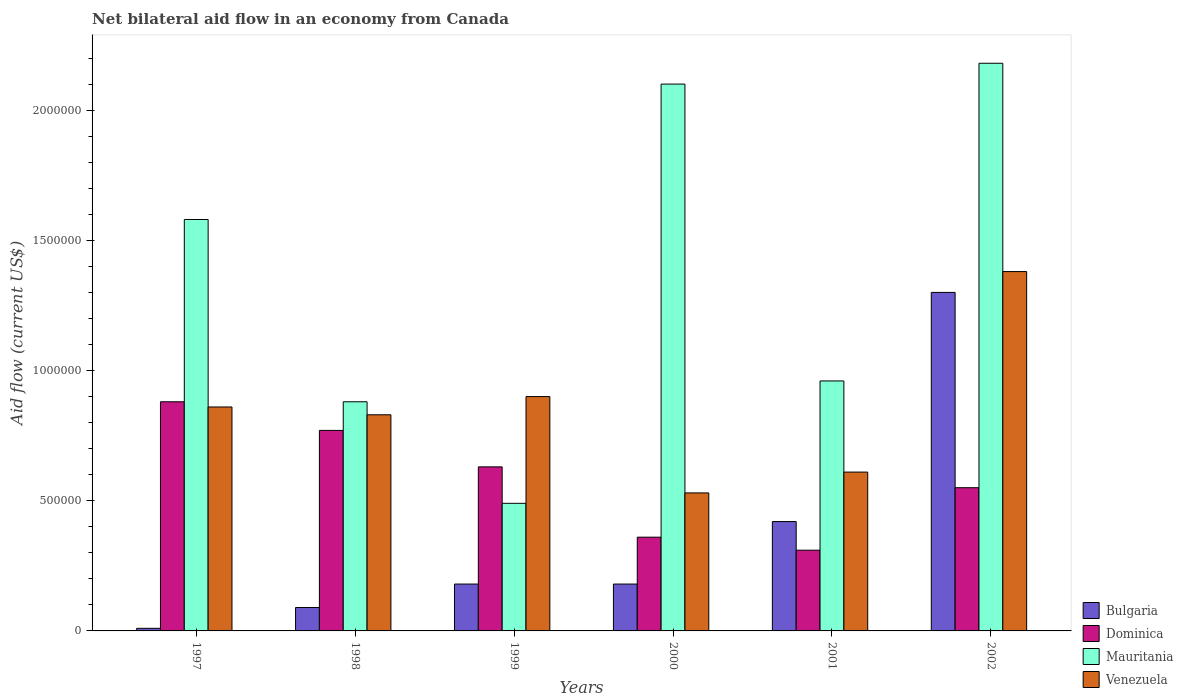How many different coloured bars are there?
Offer a terse response. 4. How many groups of bars are there?
Offer a terse response. 6. Are the number of bars on each tick of the X-axis equal?
Provide a succinct answer. Yes. How many bars are there on the 1st tick from the left?
Your response must be concise. 4. What is the net bilateral aid flow in Bulgaria in 1998?
Provide a short and direct response. 9.00e+04. Across all years, what is the maximum net bilateral aid flow in Dominica?
Your answer should be compact. 8.80e+05. In which year was the net bilateral aid flow in Mauritania minimum?
Provide a short and direct response. 1999. What is the total net bilateral aid flow in Dominica in the graph?
Your answer should be very brief. 3.50e+06. What is the difference between the net bilateral aid flow in Bulgaria in 2000 and the net bilateral aid flow in Dominica in 1998?
Offer a terse response. -5.90e+05. What is the average net bilateral aid flow in Bulgaria per year?
Ensure brevity in your answer.  3.63e+05. In the year 1998, what is the difference between the net bilateral aid flow in Bulgaria and net bilateral aid flow in Dominica?
Give a very brief answer. -6.80e+05. In how many years, is the net bilateral aid flow in Venezuela greater than 1500000 US$?
Keep it short and to the point. 0. What is the ratio of the net bilateral aid flow in Venezuela in 2001 to that in 2002?
Your answer should be very brief. 0.44. Is the net bilateral aid flow in Mauritania in 1998 less than that in 2002?
Ensure brevity in your answer.  Yes. Is the difference between the net bilateral aid flow in Bulgaria in 1999 and 2001 greater than the difference between the net bilateral aid flow in Dominica in 1999 and 2001?
Keep it short and to the point. No. What is the difference between the highest and the second highest net bilateral aid flow in Mauritania?
Your answer should be compact. 8.00e+04. What is the difference between the highest and the lowest net bilateral aid flow in Venezuela?
Your response must be concise. 8.50e+05. Is it the case that in every year, the sum of the net bilateral aid flow in Bulgaria and net bilateral aid flow in Dominica is greater than the sum of net bilateral aid flow in Venezuela and net bilateral aid flow in Mauritania?
Provide a short and direct response. No. What does the 4th bar from the left in 1999 represents?
Offer a terse response. Venezuela. What does the 1st bar from the right in 1999 represents?
Ensure brevity in your answer.  Venezuela. Are all the bars in the graph horizontal?
Provide a short and direct response. No. What is the difference between two consecutive major ticks on the Y-axis?
Your response must be concise. 5.00e+05. Where does the legend appear in the graph?
Provide a short and direct response. Bottom right. What is the title of the graph?
Offer a terse response. Net bilateral aid flow in an economy from Canada. What is the Aid flow (current US$) in Bulgaria in 1997?
Your response must be concise. 10000. What is the Aid flow (current US$) of Dominica in 1997?
Provide a succinct answer. 8.80e+05. What is the Aid flow (current US$) in Mauritania in 1997?
Your answer should be very brief. 1.58e+06. What is the Aid flow (current US$) in Venezuela in 1997?
Keep it short and to the point. 8.60e+05. What is the Aid flow (current US$) of Bulgaria in 1998?
Ensure brevity in your answer.  9.00e+04. What is the Aid flow (current US$) in Dominica in 1998?
Ensure brevity in your answer.  7.70e+05. What is the Aid flow (current US$) of Mauritania in 1998?
Offer a terse response. 8.80e+05. What is the Aid flow (current US$) in Venezuela in 1998?
Your response must be concise. 8.30e+05. What is the Aid flow (current US$) of Dominica in 1999?
Your response must be concise. 6.30e+05. What is the Aid flow (current US$) of Venezuela in 1999?
Ensure brevity in your answer.  9.00e+05. What is the Aid flow (current US$) in Bulgaria in 2000?
Your response must be concise. 1.80e+05. What is the Aid flow (current US$) in Dominica in 2000?
Provide a short and direct response. 3.60e+05. What is the Aid flow (current US$) in Mauritania in 2000?
Ensure brevity in your answer.  2.10e+06. What is the Aid flow (current US$) of Venezuela in 2000?
Ensure brevity in your answer.  5.30e+05. What is the Aid flow (current US$) of Bulgaria in 2001?
Give a very brief answer. 4.20e+05. What is the Aid flow (current US$) in Mauritania in 2001?
Make the answer very short. 9.60e+05. What is the Aid flow (current US$) in Venezuela in 2001?
Your answer should be very brief. 6.10e+05. What is the Aid flow (current US$) in Bulgaria in 2002?
Give a very brief answer. 1.30e+06. What is the Aid flow (current US$) of Dominica in 2002?
Ensure brevity in your answer.  5.50e+05. What is the Aid flow (current US$) of Mauritania in 2002?
Provide a short and direct response. 2.18e+06. What is the Aid flow (current US$) in Venezuela in 2002?
Make the answer very short. 1.38e+06. Across all years, what is the maximum Aid flow (current US$) in Bulgaria?
Provide a short and direct response. 1.30e+06. Across all years, what is the maximum Aid flow (current US$) of Dominica?
Provide a short and direct response. 8.80e+05. Across all years, what is the maximum Aid flow (current US$) of Mauritania?
Your answer should be compact. 2.18e+06. Across all years, what is the maximum Aid flow (current US$) in Venezuela?
Offer a terse response. 1.38e+06. Across all years, what is the minimum Aid flow (current US$) of Mauritania?
Make the answer very short. 4.90e+05. Across all years, what is the minimum Aid flow (current US$) of Venezuela?
Offer a very short reply. 5.30e+05. What is the total Aid flow (current US$) of Bulgaria in the graph?
Offer a terse response. 2.18e+06. What is the total Aid flow (current US$) of Dominica in the graph?
Provide a short and direct response. 3.50e+06. What is the total Aid flow (current US$) of Mauritania in the graph?
Your answer should be compact. 8.19e+06. What is the total Aid flow (current US$) of Venezuela in the graph?
Give a very brief answer. 5.11e+06. What is the difference between the Aid flow (current US$) of Bulgaria in 1997 and that in 1999?
Offer a terse response. -1.70e+05. What is the difference between the Aid flow (current US$) of Mauritania in 1997 and that in 1999?
Provide a short and direct response. 1.09e+06. What is the difference between the Aid flow (current US$) in Bulgaria in 1997 and that in 2000?
Your response must be concise. -1.70e+05. What is the difference between the Aid flow (current US$) of Dominica in 1997 and that in 2000?
Offer a terse response. 5.20e+05. What is the difference between the Aid flow (current US$) of Mauritania in 1997 and that in 2000?
Give a very brief answer. -5.20e+05. What is the difference between the Aid flow (current US$) in Venezuela in 1997 and that in 2000?
Ensure brevity in your answer.  3.30e+05. What is the difference between the Aid flow (current US$) in Bulgaria in 1997 and that in 2001?
Your answer should be compact. -4.10e+05. What is the difference between the Aid flow (current US$) of Dominica in 1997 and that in 2001?
Provide a short and direct response. 5.70e+05. What is the difference between the Aid flow (current US$) in Mauritania in 1997 and that in 2001?
Ensure brevity in your answer.  6.20e+05. What is the difference between the Aid flow (current US$) of Bulgaria in 1997 and that in 2002?
Provide a short and direct response. -1.29e+06. What is the difference between the Aid flow (current US$) in Dominica in 1997 and that in 2002?
Provide a short and direct response. 3.30e+05. What is the difference between the Aid flow (current US$) in Mauritania in 1997 and that in 2002?
Keep it short and to the point. -6.00e+05. What is the difference between the Aid flow (current US$) of Venezuela in 1997 and that in 2002?
Provide a succinct answer. -5.20e+05. What is the difference between the Aid flow (current US$) in Dominica in 1998 and that in 1999?
Your answer should be very brief. 1.40e+05. What is the difference between the Aid flow (current US$) in Bulgaria in 1998 and that in 2000?
Your answer should be very brief. -9.00e+04. What is the difference between the Aid flow (current US$) in Mauritania in 1998 and that in 2000?
Give a very brief answer. -1.22e+06. What is the difference between the Aid flow (current US$) of Bulgaria in 1998 and that in 2001?
Offer a very short reply. -3.30e+05. What is the difference between the Aid flow (current US$) of Dominica in 1998 and that in 2001?
Keep it short and to the point. 4.60e+05. What is the difference between the Aid flow (current US$) of Venezuela in 1998 and that in 2001?
Your response must be concise. 2.20e+05. What is the difference between the Aid flow (current US$) in Bulgaria in 1998 and that in 2002?
Offer a terse response. -1.21e+06. What is the difference between the Aid flow (current US$) of Dominica in 1998 and that in 2002?
Your response must be concise. 2.20e+05. What is the difference between the Aid flow (current US$) in Mauritania in 1998 and that in 2002?
Your answer should be compact. -1.30e+06. What is the difference between the Aid flow (current US$) in Venezuela in 1998 and that in 2002?
Provide a short and direct response. -5.50e+05. What is the difference between the Aid flow (current US$) in Bulgaria in 1999 and that in 2000?
Ensure brevity in your answer.  0. What is the difference between the Aid flow (current US$) of Mauritania in 1999 and that in 2000?
Your response must be concise. -1.61e+06. What is the difference between the Aid flow (current US$) of Venezuela in 1999 and that in 2000?
Offer a terse response. 3.70e+05. What is the difference between the Aid flow (current US$) of Dominica in 1999 and that in 2001?
Your response must be concise. 3.20e+05. What is the difference between the Aid flow (current US$) in Mauritania in 1999 and that in 2001?
Your response must be concise. -4.70e+05. What is the difference between the Aid flow (current US$) in Venezuela in 1999 and that in 2001?
Give a very brief answer. 2.90e+05. What is the difference between the Aid flow (current US$) in Bulgaria in 1999 and that in 2002?
Your response must be concise. -1.12e+06. What is the difference between the Aid flow (current US$) of Mauritania in 1999 and that in 2002?
Make the answer very short. -1.69e+06. What is the difference between the Aid flow (current US$) of Venezuela in 1999 and that in 2002?
Your answer should be very brief. -4.80e+05. What is the difference between the Aid flow (current US$) of Bulgaria in 2000 and that in 2001?
Your answer should be very brief. -2.40e+05. What is the difference between the Aid flow (current US$) of Mauritania in 2000 and that in 2001?
Give a very brief answer. 1.14e+06. What is the difference between the Aid flow (current US$) in Venezuela in 2000 and that in 2001?
Offer a very short reply. -8.00e+04. What is the difference between the Aid flow (current US$) in Bulgaria in 2000 and that in 2002?
Your response must be concise. -1.12e+06. What is the difference between the Aid flow (current US$) in Venezuela in 2000 and that in 2002?
Your response must be concise. -8.50e+05. What is the difference between the Aid flow (current US$) of Bulgaria in 2001 and that in 2002?
Provide a succinct answer. -8.80e+05. What is the difference between the Aid flow (current US$) in Mauritania in 2001 and that in 2002?
Your answer should be very brief. -1.22e+06. What is the difference between the Aid flow (current US$) in Venezuela in 2001 and that in 2002?
Your answer should be compact. -7.70e+05. What is the difference between the Aid flow (current US$) in Bulgaria in 1997 and the Aid flow (current US$) in Dominica in 1998?
Ensure brevity in your answer.  -7.60e+05. What is the difference between the Aid flow (current US$) in Bulgaria in 1997 and the Aid flow (current US$) in Mauritania in 1998?
Provide a succinct answer. -8.70e+05. What is the difference between the Aid flow (current US$) in Bulgaria in 1997 and the Aid flow (current US$) in Venezuela in 1998?
Your answer should be compact. -8.20e+05. What is the difference between the Aid flow (current US$) of Mauritania in 1997 and the Aid flow (current US$) of Venezuela in 1998?
Make the answer very short. 7.50e+05. What is the difference between the Aid flow (current US$) of Bulgaria in 1997 and the Aid flow (current US$) of Dominica in 1999?
Give a very brief answer. -6.20e+05. What is the difference between the Aid flow (current US$) in Bulgaria in 1997 and the Aid flow (current US$) in Mauritania in 1999?
Provide a succinct answer. -4.80e+05. What is the difference between the Aid flow (current US$) of Bulgaria in 1997 and the Aid flow (current US$) of Venezuela in 1999?
Give a very brief answer. -8.90e+05. What is the difference between the Aid flow (current US$) in Dominica in 1997 and the Aid flow (current US$) in Mauritania in 1999?
Your answer should be very brief. 3.90e+05. What is the difference between the Aid flow (current US$) of Mauritania in 1997 and the Aid flow (current US$) of Venezuela in 1999?
Keep it short and to the point. 6.80e+05. What is the difference between the Aid flow (current US$) of Bulgaria in 1997 and the Aid flow (current US$) of Dominica in 2000?
Provide a succinct answer. -3.50e+05. What is the difference between the Aid flow (current US$) of Bulgaria in 1997 and the Aid flow (current US$) of Mauritania in 2000?
Give a very brief answer. -2.09e+06. What is the difference between the Aid flow (current US$) of Bulgaria in 1997 and the Aid flow (current US$) of Venezuela in 2000?
Offer a terse response. -5.20e+05. What is the difference between the Aid flow (current US$) in Dominica in 1997 and the Aid flow (current US$) in Mauritania in 2000?
Give a very brief answer. -1.22e+06. What is the difference between the Aid flow (current US$) of Mauritania in 1997 and the Aid flow (current US$) of Venezuela in 2000?
Give a very brief answer. 1.05e+06. What is the difference between the Aid flow (current US$) of Bulgaria in 1997 and the Aid flow (current US$) of Mauritania in 2001?
Keep it short and to the point. -9.50e+05. What is the difference between the Aid flow (current US$) of Bulgaria in 1997 and the Aid flow (current US$) of Venezuela in 2001?
Your response must be concise. -6.00e+05. What is the difference between the Aid flow (current US$) of Dominica in 1997 and the Aid flow (current US$) of Mauritania in 2001?
Make the answer very short. -8.00e+04. What is the difference between the Aid flow (current US$) in Mauritania in 1997 and the Aid flow (current US$) in Venezuela in 2001?
Provide a succinct answer. 9.70e+05. What is the difference between the Aid flow (current US$) of Bulgaria in 1997 and the Aid flow (current US$) of Dominica in 2002?
Make the answer very short. -5.40e+05. What is the difference between the Aid flow (current US$) of Bulgaria in 1997 and the Aid flow (current US$) of Mauritania in 2002?
Your response must be concise. -2.17e+06. What is the difference between the Aid flow (current US$) in Bulgaria in 1997 and the Aid flow (current US$) in Venezuela in 2002?
Offer a terse response. -1.37e+06. What is the difference between the Aid flow (current US$) of Dominica in 1997 and the Aid flow (current US$) of Mauritania in 2002?
Your answer should be compact. -1.30e+06. What is the difference between the Aid flow (current US$) in Dominica in 1997 and the Aid flow (current US$) in Venezuela in 2002?
Offer a terse response. -5.00e+05. What is the difference between the Aid flow (current US$) in Mauritania in 1997 and the Aid flow (current US$) in Venezuela in 2002?
Make the answer very short. 2.00e+05. What is the difference between the Aid flow (current US$) in Bulgaria in 1998 and the Aid flow (current US$) in Dominica in 1999?
Give a very brief answer. -5.40e+05. What is the difference between the Aid flow (current US$) of Bulgaria in 1998 and the Aid flow (current US$) of Mauritania in 1999?
Give a very brief answer. -4.00e+05. What is the difference between the Aid flow (current US$) of Bulgaria in 1998 and the Aid flow (current US$) of Venezuela in 1999?
Give a very brief answer. -8.10e+05. What is the difference between the Aid flow (current US$) of Dominica in 1998 and the Aid flow (current US$) of Venezuela in 1999?
Offer a terse response. -1.30e+05. What is the difference between the Aid flow (current US$) of Mauritania in 1998 and the Aid flow (current US$) of Venezuela in 1999?
Provide a succinct answer. -2.00e+04. What is the difference between the Aid flow (current US$) of Bulgaria in 1998 and the Aid flow (current US$) of Dominica in 2000?
Give a very brief answer. -2.70e+05. What is the difference between the Aid flow (current US$) in Bulgaria in 1998 and the Aid flow (current US$) in Mauritania in 2000?
Provide a succinct answer. -2.01e+06. What is the difference between the Aid flow (current US$) of Bulgaria in 1998 and the Aid flow (current US$) of Venezuela in 2000?
Ensure brevity in your answer.  -4.40e+05. What is the difference between the Aid flow (current US$) of Dominica in 1998 and the Aid flow (current US$) of Mauritania in 2000?
Your answer should be compact. -1.33e+06. What is the difference between the Aid flow (current US$) of Dominica in 1998 and the Aid flow (current US$) of Venezuela in 2000?
Offer a terse response. 2.40e+05. What is the difference between the Aid flow (current US$) of Mauritania in 1998 and the Aid flow (current US$) of Venezuela in 2000?
Make the answer very short. 3.50e+05. What is the difference between the Aid flow (current US$) of Bulgaria in 1998 and the Aid flow (current US$) of Mauritania in 2001?
Offer a terse response. -8.70e+05. What is the difference between the Aid flow (current US$) of Bulgaria in 1998 and the Aid flow (current US$) of Venezuela in 2001?
Keep it short and to the point. -5.20e+05. What is the difference between the Aid flow (current US$) in Dominica in 1998 and the Aid flow (current US$) in Mauritania in 2001?
Your response must be concise. -1.90e+05. What is the difference between the Aid flow (current US$) of Bulgaria in 1998 and the Aid flow (current US$) of Dominica in 2002?
Offer a very short reply. -4.60e+05. What is the difference between the Aid flow (current US$) in Bulgaria in 1998 and the Aid flow (current US$) in Mauritania in 2002?
Ensure brevity in your answer.  -2.09e+06. What is the difference between the Aid flow (current US$) of Bulgaria in 1998 and the Aid flow (current US$) of Venezuela in 2002?
Your answer should be compact. -1.29e+06. What is the difference between the Aid flow (current US$) of Dominica in 1998 and the Aid flow (current US$) of Mauritania in 2002?
Keep it short and to the point. -1.41e+06. What is the difference between the Aid flow (current US$) in Dominica in 1998 and the Aid flow (current US$) in Venezuela in 2002?
Give a very brief answer. -6.10e+05. What is the difference between the Aid flow (current US$) in Mauritania in 1998 and the Aid flow (current US$) in Venezuela in 2002?
Provide a succinct answer. -5.00e+05. What is the difference between the Aid flow (current US$) of Bulgaria in 1999 and the Aid flow (current US$) of Mauritania in 2000?
Offer a terse response. -1.92e+06. What is the difference between the Aid flow (current US$) of Bulgaria in 1999 and the Aid flow (current US$) of Venezuela in 2000?
Offer a terse response. -3.50e+05. What is the difference between the Aid flow (current US$) of Dominica in 1999 and the Aid flow (current US$) of Mauritania in 2000?
Ensure brevity in your answer.  -1.47e+06. What is the difference between the Aid flow (current US$) in Bulgaria in 1999 and the Aid flow (current US$) in Mauritania in 2001?
Offer a terse response. -7.80e+05. What is the difference between the Aid flow (current US$) in Bulgaria in 1999 and the Aid flow (current US$) in Venezuela in 2001?
Offer a terse response. -4.30e+05. What is the difference between the Aid flow (current US$) in Dominica in 1999 and the Aid flow (current US$) in Mauritania in 2001?
Your response must be concise. -3.30e+05. What is the difference between the Aid flow (current US$) of Dominica in 1999 and the Aid flow (current US$) of Venezuela in 2001?
Your answer should be compact. 2.00e+04. What is the difference between the Aid flow (current US$) of Bulgaria in 1999 and the Aid flow (current US$) of Dominica in 2002?
Provide a short and direct response. -3.70e+05. What is the difference between the Aid flow (current US$) of Bulgaria in 1999 and the Aid flow (current US$) of Venezuela in 2002?
Your answer should be very brief. -1.20e+06. What is the difference between the Aid flow (current US$) in Dominica in 1999 and the Aid flow (current US$) in Mauritania in 2002?
Offer a very short reply. -1.55e+06. What is the difference between the Aid flow (current US$) in Dominica in 1999 and the Aid flow (current US$) in Venezuela in 2002?
Give a very brief answer. -7.50e+05. What is the difference between the Aid flow (current US$) of Mauritania in 1999 and the Aid flow (current US$) of Venezuela in 2002?
Give a very brief answer. -8.90e+05. What is the difference between the Aid flow (current US$) in Bulgaria in 2000 and the Aid flow (current US$) in Mauritania in 2001?
Offer a terse response. -7.80e+05. What is the difference between the Aid flow (current US$) in Bulgaria in 2000 and the Aid flow (current US$) in Venezuela in 2001?
Provide a succinct answer. -4.30e+05. What is the difference between the Aid flow (current US$) in Dominica in 2000 and the Aid flow (current US$) in Mauritania in 2001?
Offer a terse response. -6.00e+05. What is the difference between the Aid flow (current US$) of Dominica in 2000 and the Aid flow (current US$) of Venezuela in 2001?
Your response must be concise. -2.50e+05. What is the difference between the Aid flow (current US$) in Mauritania in 2000 and the Aid flow (current US$) in Venezuela in 2001?
Give a very brief answer. 1.49e+06. What is the difference between the Aid flow (current US$) in Bulgaria in 2000 and the Aid flow (current US$) in Dominica in 2002?
Your answer should be compact. -3.70e+05. What is the difference between the Aid flow (current US$) in Bulgaria in 2000 and the Aid flow (current US$) in Venezuela in 2002?
Your response must be concise. -1.20e+06. What is the difference between the Aid flow (current US$) in Dominica in 2000 and the Aid flow (current US$) in Mauritania in 2002?
Your response must be concise. -1.82e+06. What is the difference between the Aid flow (current US$) of Dominica in 2000 and the Aid flow (current US$) of Venezuela in 2002?
Your response must be concise. -1.02e+06. What is the difference between the Aid flow (current US$) in Mauritania in 2000 and the Aid flow (current US$) in Venezuela in 2002?
Provide a succinct answer. 7.20e+05. What is the difference between the Aid flow (current US$) in Bulgaria in 2001 and the Aid flow (current US$) in Mauritania in 2002?
Provide a succinct answer. -1.76e+06. What is the difference between the Aid flow (current US$) of Bulgaria in 2001 and the Aid flow (current US$) of Venezuela in 2002?
Your response must be concise. -9.60e+05. What is the difference between the Aid flow (current US$) in Dominica in 2001 and the Aid flow (current US$) in Mauritania in 2002?
Provide a short and direct response. -1.87e+06. What is the difference between the Aid flow (current US$) of Dominica in 2001 and the Aid flow (current US$) of Venezuela in 2002?
Make the answer very short. -1.07e+06. What is the difference between the Aid flow (current US$) in Mauritania in 2001 and the Aid flow (current US$) in Venezuela in 2002?
Offer a very short reply. -4.20e+05. What is the average Aid flow (current US$) in Bulgaria per year?
Your response must be concise. 3.63e+05. What is the average Aid flow (current US$) of Dominica per year?
Keep it short and to the point. 5.83e+05. What is the average Aid flow (current US$) in Mauritania per year?
Offer a terse response. 1.36e+06. What is the average Aid flow (current US$) in Venezuela per year?
Make the answer very short. 8.52e+05. In the year 1997, what is the difference between the Aid flow (current US$) in Bulgaria and Aid flow (current US$) in Dominica?
Keep it short and to the point. -8.70e+05. In the year 1997, what is the difference between the Aid flow (current US$) in Bulgaria and Aid flow (current US$) in Mauritania?
Your answer should be very brief. -1.57e+06. In the year 1997, what is the difference between the Aid flow (current US$) of Bulgaria and Aid flow (current US$) of Venezuela?
Give a very brief answer. -8.50e+05. In the year 1997, what is the difference between the Aid flow (current US$) of Dominica and Aid flow (current US$) of Mauritania?
Your answer should be compact. -7.00e+05. In the year 1997, what is the difference between the Aid flow (current US$) of Mauritania and Aid flow (current US$) of Venezuela?
Ensure brevity in your answer.  7.20e+05. In the year 1998, what is the difference between the Aid flow (current US$) in Bulgaria and Aid flow (current US$) in Dominica?
Ensure brevity in your answer.  -6.80e+05. In the year 1998, what is the difference between the Aid flow (current US$) in Bulgaria and Aid flow (current US$) in Mauritania?
Make the answer very short. -7.90e+05. In the year 1998, what is the difference between the Aid flow (current US$) in Bulgaria and Aid flow (current US$) in Venezuela?
Provide a succinct answer. -7.40e+05. In the year 1998, what is the difference between the Aid flow (current US$) in Mauritania and Aid flow (current US$) in Venezuela?
Your response must be concise. 5.00e+04. In the year 1999, what is the difference between the Aid flow (current US$) of Bulgaria and Aid flow (current US$) of Dominica?
Your response must be concise. -4.50e+05. In the year 1999, what is the difference between the Aid flow (current US$) of Bulgaria and Aid flow (current US$) of Mauritania?
Ensure brevity in your answer.  -3.10e+05. In the year 1999, what is the difference between the Aid flow (current US$) in Bulgaria and Aid flow (current US$) in Venezuela?
Give a very brief answer. -7.20e+05. In the year 1999, what is the difference between the Aid flow (current US$) of Dominica and Aid flow (current US$) of Mauritania?
Your answer should be compact. 1.40e+05. In the year 1999, what is the difference between the Aid flow (current US$) in Dominica and Aid flow (current US$) in Venezuela?
Provide a succinct answer. -2.70e+05. In the year 1999, what is the difference between the Aid flow (current US$) in Mauritania and Aid flow (current US$) in Venezuela?
Ensure brevity in your answer.  -4.10e+05. In the year 2000, what is the difference between the Aid flow (current US$) of Bulgaria and Aid flow (current US$) of Mauritania?
Give a very brief answer. -1.92e+06. In the year 2000, what is the difference between the Aid flow (current US$) in Bulgaria and Aid flow (current US$) in Venezuela?
Ensure brevity in your answer.  -3.50e+05. In the year 2000, what is the difference between the Aid flow (current US$) in Dominica and Aid flow (current US$) in Mauritania?
Offer a very short reply. -1.74e+06. In the year 2000, what is the difference between the Aid flow (current US$) in Dominica and Aid flow (current US$) in Venezuela?
Ensure brevity in your answer.  -1.70e+05. In the year 2000, what is the difference between the Aid flow (current US$) of Mauritania and Aid flow (current US$) of Venezuela?
Your answer should be very brief. 1.57e+06. In the year 2001, what is the difference between the Aid flow (current US$) in Bulgaria and Aid flow (current US$) in Dominica?
Provide a short and direct response. 1.10e+05. In the year 2001, what is the difference between the Aid flow (current US$) in Bulgaria and Aid flow (current US$) in Mauritania?
Provide a succinct answer. -5.40e+05. In the year 2001, what is the difference between the Aid flow (current US$) in Dominica and Aid flow (current US$) in Mauritania?
Keep it short and to the point. -6.50e+05. In the year 2001, what is the difference between the Aid flow (current US$) of Mauritania and Aid flow (current US$) of Venezuela?
Offer a very short reply. 3.50e+05. In the year 2002, what is the difference between the Aid flow (current US$) in Bulgaria and Aid flow (current US$) in Dominica?
Provide a succinct answer. 7.50e+05. In the year 2002, what is the difference between the Aid flow (current US$) of Bulgaria and Aid flow (current US$) of Mauritania?
Provide a succinct answer. -8.80e+05. In the year 2002, what is the difference between the Aid flow (current US$) of Dominica and Aid flow (current US$) of Mauritania?
Provide a short and direct response. -1.63e+06. In the year 2002, what is the difference between the Aid flow (current US$) of Dominica and Aid flow (current US$) of Venezuela?
Offer a terse response. -8.30e+05. What is the ratio of the Aid flow (current US$) in Bulgaria in 1997 to that in 1998?
Offer a very short reply. 0.11. What is the ratio of the Aid flow (current US$) of Dominica in 1997 to that in 1998?
Ensure brevity in your answer.  1.14. What is the ratio of the Aid flow (current US$) of Mauritania in 1997 to that in 1998?
Keep it short and to the point. 1.8. What is the ratio of the Aid flow (current US$) in Venezuela in 1997 to that in 1998?
Your answer should be compact. 1.04. What is the ratio of the Aid flow (current US$) of Bulgaria in 1997 to that in 1999?
Make the answer very short. 0.06. What is the ratio of the Aid flow (current US$) of Dominica in 1997 to that in 1999?
Keep it short and to the point. 1.4. What is the ratio of the Aid flow (current US$) in Mauritania in 1997 to that in 1999?
Provide a succinct answer. 3.22. What is the ratio of the Aid flow (current US$) in Venezuela in 1997 to that in 1999?
Provide a short and direct response. 0.96. What is the ratio of the Aid flow (current US$) in Bulgaria in 1997 to that in 2000?
Provide a succinct answer. 0.06. What is the ratio of the Aid flow (current US$) in Dominica in 1997 to that in 2000?
Provide a succinct answer. 2.44. What is the ratio of the Aid flow (current US$) of Mauritania in 1997 to that in 2000?
Give a very brief answer. 0.75. What is the ratio of the Aid flow (current US$) of Venezuela in 1997 to that in 2000?
Your answer should be compact. 1.62. What is the ratio of the Aid flow (current US$) of Bulgaria in 1997 to that in 2001?
Ensure brevity in your answer.  0.02. What is the ratio of the Aid flow (current US$) in Dominica in 1997 to that in 2001?
Your answer should be compact. 2.84. What is the ratio of the Aid flow (current US$) in Mauritania in 1997 to that in 2001?
Provide a short and direct response. 1.65. What is the ratio of the Aid flow (current US$) in Venezuela in 1997 to that in 2001?
Provide a succinct answer. 1.41. What is the ratio of the Aid flow (current US$) in Bulgaria in 1997 to that in 2002?
Offer a terse response. 0.01. What is the ratio of the Aid flow (current US$) of Dominica in 1997 to that in 2002?
Keep it short and to the point. 1.6. What is the ratio of the Aid flow (current US$) of Mauritania in 1997 to that in 2002?
Your answer should be compact. 0.72. What is the ratio of the Aid flow (current US$) of Venezuela in 1997 to that in 2002?
Offer a very short reply. 0.62. What is the ratio of the Aid flow (current US$) in Bulgaria in 1998 to that in 1999?
Ensure brevity in your answer.  0.5. What is the ratio of the Aid flow (current US$) of Dominica in 1998 to that in 1999?
Ensure brevity in your answer.  1.22. What is the ratio of the Aid flow (current US$) in Mauritania in 1998 to that in 1999?
Make the answer very short. 1.8. What is the ratio of the Aid flow (current US$) in Venezuela in 1998 to that in 1999?
Your answer should be very brief. 0.92. What is the ratio of the Aid flow (current US$) in Bulgaria in 1998 to that in 2000?
Offer a very short reply. 0.5. What is the ratio of the Aid flow (current US$) of Dominica in 1998 to that in 2000?
Provide a short and direct response. 2.14. What is the ratio of the Aid flow (current US$) of Mauritania in 1998 to that in 2000?
Offer a very short reply. 0.42. What is the ratio of the Aid flow (current US$) of Venezuela in 1998 to that in 2000?
Offer a very short reply. 1.57. What is the ratio of the Aid flow (current US$) in Bulgaria in 1998 to that in 2001?
Ensure brevity in your answer.  0.21. What is the ratio of the Aid flow (current US$) of Dominica in 1998 to that in 2001?
Provide a short and direct response. 2.48. What is the ratio of the Aid flow (current US$) of Mauritania in 1998 to that in 2001?
Your response must be concise. 0.92. What is the ratio of the Aid flow (current US$) in Venezuela in 1998 to that in 2001?
Give a very brief answer. 1.36. What is the ratio of the Aid flow (current US$) in Bulgaria in 1998 to that in 2002?
Your answer should be very brief. 0.07. What is the ratio of the Aid flow (current US$) in Mauritania in 1998 to that in 2002?
Provide a short and direct response. 0.4. What is the ratio of the Aid flow (current US$) of Venezuela in 1998 to that in 2002?
Ensure brevity in your answer.  0.6. What is the ratio of the Aid flow (current US$) of Dominica in 1999 to that in 2000?
Provide a succinct answer. 1.75. What is the ratio of the Aid flow (current US$) of Mauritania in 1999 to that in 2000?
Your answer should be compact. 0.23. What is the ratio of the Aid flow (current US$) of Venezuela in 1999 to that in 2000?
Your answer should be compact. 1.7. What is the ratio of the Aid flow (current US$) of Bulgaria in 1999 to that in 2001?
Your response must be concise. 0.43. What is the ratio of the Aid flow (current US$) in Dominica in 1999 to that in 2001?
Ensure brevity in your answer.  2.03. What is the ratio of the Aid flow (current US$) in Mauritania in 1999 to that in 2001?
Your response must be concise. 0.51. What is the ratio of the Aid flow (current US$) of Venezuela in 1999 to that in 2001?
Make the answer very short. 1.48. What is the ratio of the Aid flow (current US$) of Bulgaria in 1999 to that in 2002?
Your answer should be compact. 0.14. What is the ratio of the Aid flow (current US$) of Dominica in 1999 to that in 2002?
Provide a succinct answer. 1.15. What is the ratio of the Aid flow (current US$) of Mauritania in 1999 to that in 2002?
Your answer should be compact. 0.22. What is the ratio of the Aid flow (current US$) in Venezuela in 1999 to that in 2002?
Give a very brief answer. 0.65. What is the ratio of the Aid flow (current US$) of Bulgaria in 2000 to that in 2001?
Offer a terse response. 0.43. What is the ratio of the Aid flow (current US$) in Dominica in 2000 to that in 2001?
Your response must be concise. 1.16. What is the ratio of the Aid flow (current US$) in Mauritania in 2000 to that in 2001?
Your answer should be compact. 2.19. What is the ratio of the Aid flow (current US$) in Venezuela in 2000 to that in 2001?
Offer a terse response. 0.87. What is the ratio of the Aid flow (current US$) of Bulgaria in 2000 to that in 2002?
Offer a very short reply. 0.14. What is the ratio of the Aid flow (current US$) in Dominica in 2000 to that in 2002?
Your response must be concise. 0.65. What is the ratio of the Aid flow (current US$) of Mauritania in 2000 to that in 2002?
Offer a terse response. 0.96. What is the ratio of the Aid flow (current US$) of Venezuela in 2000 to that in 2002?
Offer a terse response. 0.38. What is the ratio of the Aid flow (current US$) in Bulgaria in 2001 to that in 2002?
Provide a short and direct response. 0.32. What is the ratio of the Aid flow (current US$) in Dominica in 2001 to that in 2002?
Make the answer very short. 0.56. What is the ratio of the Aid flow (current US$) in Mauritania in 2001 to that in 2002?
Your answer should be very brief. 0.44. What is the ratio of the Aid flow (current US$) in Venezuela in 2001 to that in 2002?
Offer a terse response. 0.44. What is the difference between the highest and the second highest Aid flow (current US$) in Bulgaria?
Offer a terse response. 8.80e+05. What is the difference between the highest and the second highest Aid flow (current US$) in Dominica?
Provide a short and direct response. 1.10e+05. What is the difference between the highest and the second highest Aid flow (current US$) in Mauritania?
Ensure brevity in your answer.  8.00e+04. What is the difference between the highest and the second highest Aid flow (current US$) in Venezuela?
Offer a very short reply. 4.80e+05. What is the difference between the highest and the lowest Aid flow (current US$) in Bulgaria?
Keep it short and to the point. 1.29e+06. What is the difference between the highest and the lowest Aid flow (current US$) in Dominica?
Ensure brevity in your answer.  5.70e+05. What is the difference between the highest and the lowest Aid flow (current US$) of Mauritania?
Give a very brief answer. 1.69e+06. What is the difference between the highest and the lowest Aid flow (current US$) of Venezuela?
Your response must be concise. 8.50e+05. 